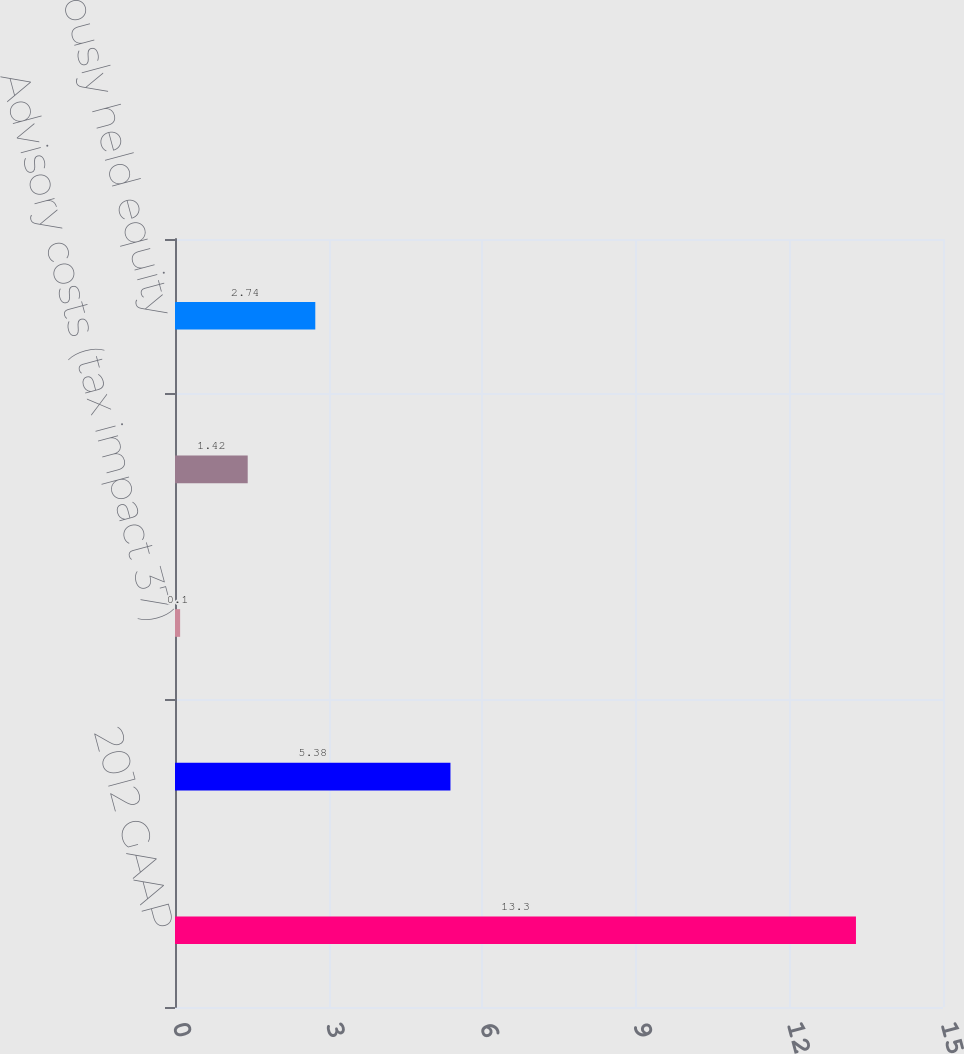Convert chart. <chart><loc_0><loc_0><loc_500><loc_500><bar_chart><fcel>2012 GAAP<fcel>Business restructuring and<fcel>Advisory costs (tax impact 37)<fcel>Customer bankruptcy (tax<fcel>Gain on previously held equity<nl><fcel>13.3<fcel>5.38<fcel>0.1<fcel>1.42<fcel>2.74<nl></chart> 